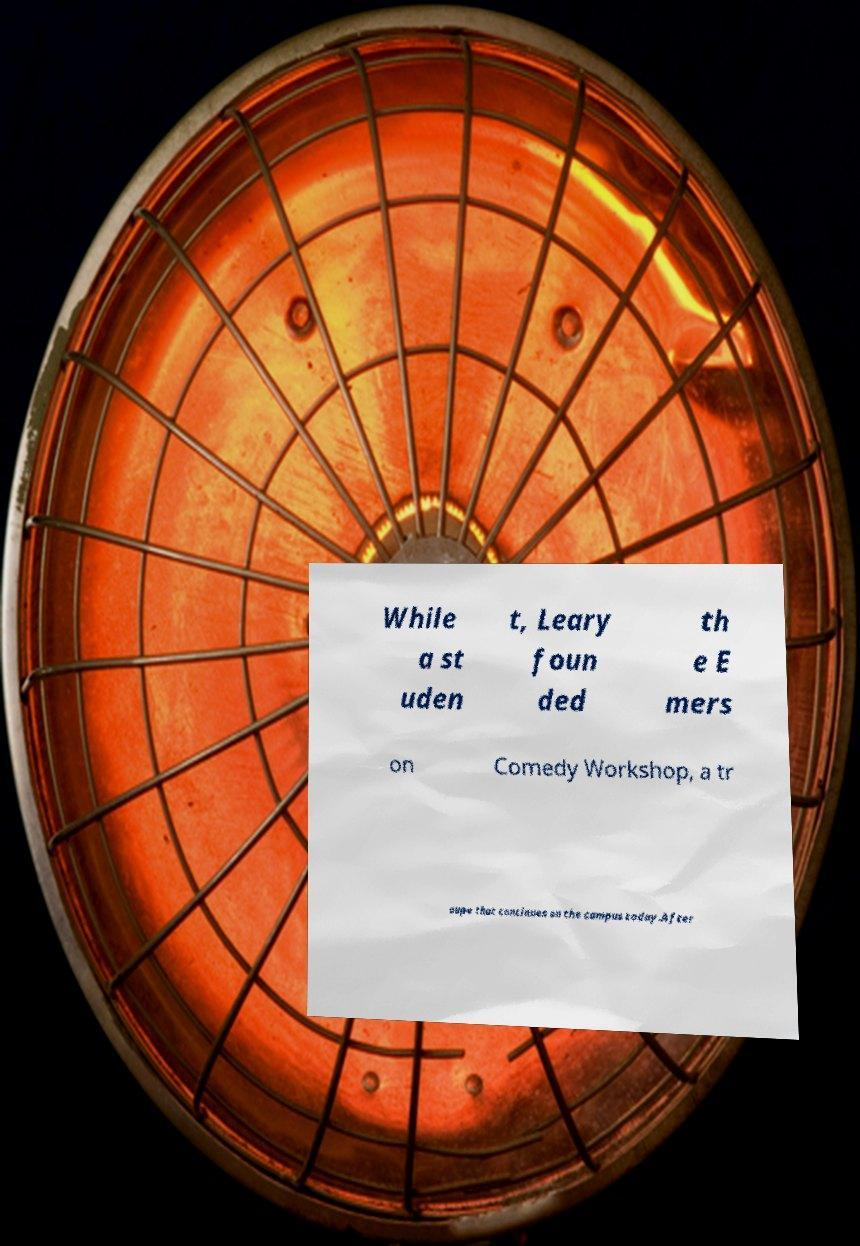For documentation purposes, I need the text within this image transcribed. Could you provide that? While a st uden t, Leary foun ded th e E mers on Comedy Workshop, a tr oupe that continues on the campus today.After 